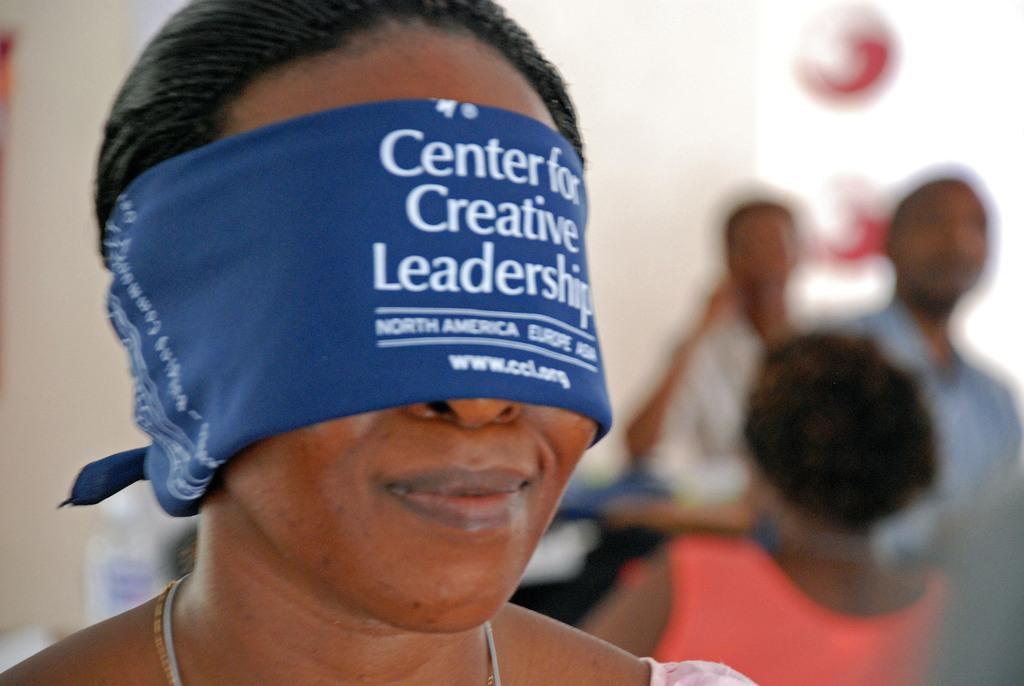Who is the main subject in the image? There is a woman in the image. What is the woman wearing on her eyes? The woman is wearing a blue blindfold. Can you describe the background of the image? There are people in the background of the image. How many goldfish can be seen swimming in the image? There are no goldfish present in the image. What type of goose is standing in the middle of the image? There is no goose present in the image. 